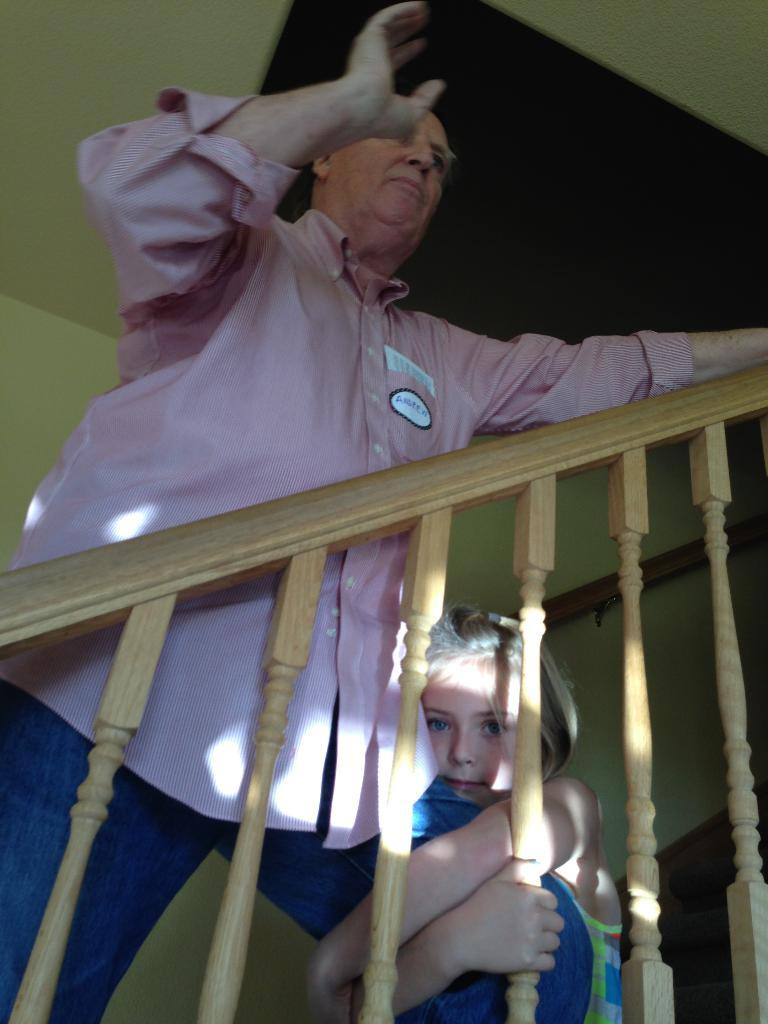What is the main subject in the center of the image? There is a man standing in the center of the image. What is the kid doing in relation to the man? A kid is holding the man's leg. What can be seen in the background of the image? There is a wall, a roof, a fence, and a staircase in the background of the image. What discovery was made by the deer in the image? There are no deer present in the image, so no discovery can be attributed to them. 